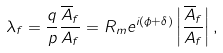<formula> <loc_0><loc_0><loc_500><loc_500>\lambda _ { f } = \frac { q } { p } \frac { { \overline { A } } _ { f } } { A _ { f } } = R _ { m } e ^ { i ( \phi + \delta ) } \left | \frac { { \overline { A } } _ { f } } { A _ { f } } \right | ,</formula> 